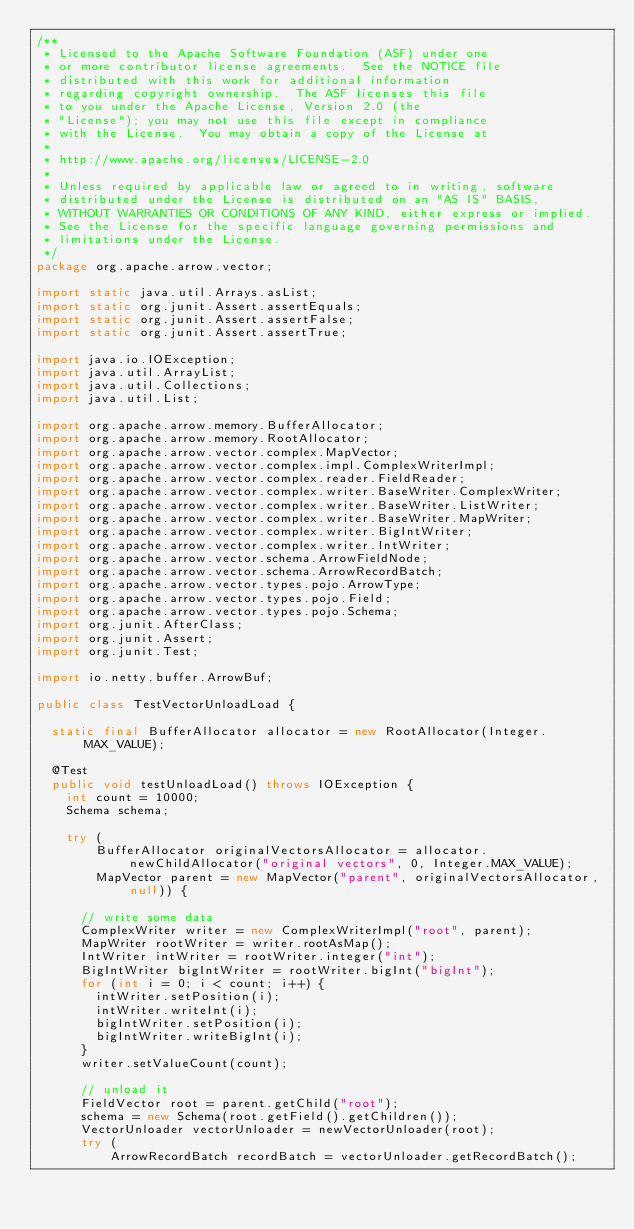Convert code to text. <code><loc_0><loc_0><loc_500><loc_500><_Java_>/**
 * Licensed to the Apache Software Foundation (ASF) under one
 * or more contributor license agreements.  See the NOTICE file
 * distributed with this work for additional information
 * regarding copyright ownership.  The ASF licenses this file
 * to you under the Apache License, Version 2.0 (the
 * "License"); you may not use this file except in compliance
 * with the License.  You may obtain a copy of the License at
 *
 * http://www.apache.org/licenses/LICENSE-2.0
 *
 * Unless required by applicable law or agreed to in writing, software
 * distributed under the License is distributed on an "AS IS" BASIS,
 * WITHOUT WARRANTIES OR CONDITIONS OF ANY KIND, either express or implied.
 * See the License for the specific language governing permissions and
 * limitations under the License.
 */
package org.apache.arrow.vector;

import static java.util.Arrays.asList;
import static org.junit.Assert.assertEquals;
import static org.junit.Assert.assertFalse;
import static org.junit.Assert.assertTrue;

import java.io.IOException;
import java.util.ArrayList;
import java.util.Collections;
import java.util.List;

import org.apache.arrow.memory.BufferAllocator;
import org.apache.arrow.memory.RootAllocator;
import org.apache.arrow.vector.complex.MapVector;
import org.apache.arrow.vector.complex.impl.ComplexWriterImpl;
import org.apache.arrow.vector.complex.reader.FieldReader;
import org.apache.arrow.vector.complex.writer.BaseWriter.ComplexWriter;
import org.apache.arrow.vector.complex.writer.BaseWriter.ListWriter;
import org.apache.arrow.vector.complex.writer.BaseWriter.MapWriter;
import org.apache.arrow.vector.complex.writer.BigIntWriter;
import org.apache.arrow.vector.complex.writer.IntWriter;
import org.apache.arrow.vector.schema.ArrowFieldNode;
import org.apache.arrow.vector.schema.ArrowRecordBatch;
import org.apache.arrow.vector.types.pojo.ArrowType;
import org.apache.arrow.vector.types.pojo.Field;
import org.apache.arrow.vector.types.pojo.Schema;
import org.junit.AfterClass;
import org.junit.Assert;
import org.junit.Test;

import io.netty.buffer.ArrowBuf;

public class TestVectorUnloadLoad {

  static final BufferAllocator allocator = new RootAllocator(Integer.MAX_VALUE);

  @Test
  public void testUnloadLoad() throws IOException {
    int count = 10000;
    Schema schema;

    try (
        BufferAllocator originalVectorsAllocator = allocator.newChildAllocator("original vectors", 0, Integer.MAX_VALUE);
        MapVector parent = new MapVector("parent", originalVectorsAllocator, null)) {

      // write some data
      ComplexWriter writer = new ComplexWriterImpl("root", parent);
      MapWriter rootWriter = writer.rootAsMap();
      IntWriter intWriter = rootWriter.integer("int");
      BigIntWriter bigIntWriter = rootWriter.bigInt("bigInt");
      for (int i = 0; i < count; i++) {
        intWriter.setPosition(i);
        intWriter.writeInt(i);
        bigIntWriter.setPosition(i);
        bigIntWriter.writeBigInt(i);
      }
      writer.setValueCount(count);

      // unload it
      FieldVector root = parent.getChild("root");
      schema = new Schema(root.getField().getChildren());
      VectorUnloader vectorUnloader = newVectorUnloader(root);
      try (
          ArrowRecordBatch recordBatch = vectorUnloader.getRecordBatch();</code> 